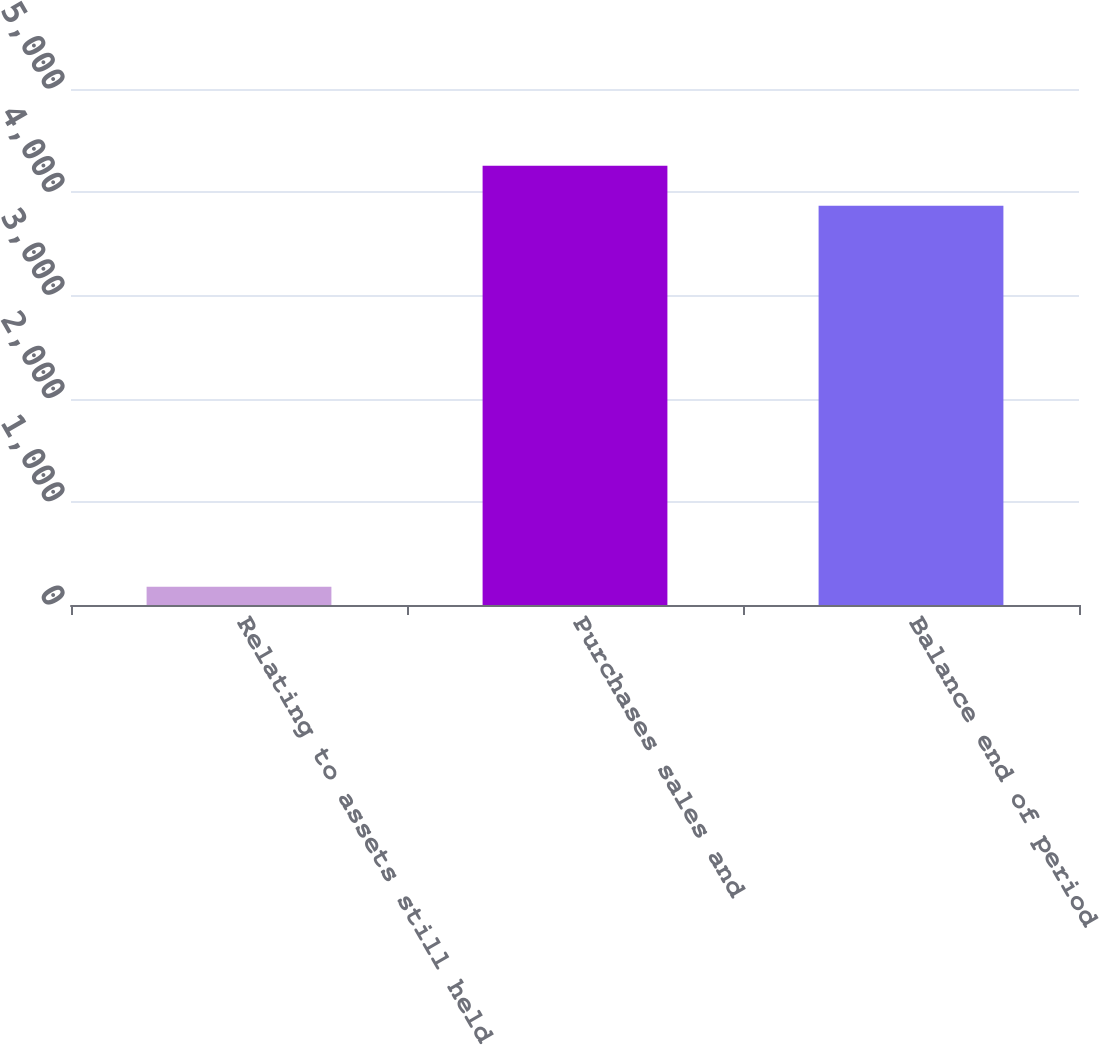Convert chart. <chart><loc_0><loc_0><loc_500><loc_500><bar_chart><fcel>Relating to assets still held<fcel>Purchases sales and<fcel>Balance end of period<nl><fcel>178<fcel>4255.9<fcel>3869<nl></chart> 